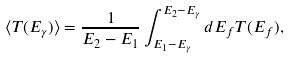<formula> <loc_0><loc_0><loc_500><loc_500>\langle T ( E _ { \gamma } ) \rangle = \frac { 1 } { E _ { 2 } - E _ { 1 } } \int _ { E _ { 1 } - E _ { \gamma } } ^ { E _ { 2 } - E _ { \gamma } } { d } E _ { f } T ( E _ { f } ) ,</formula> 